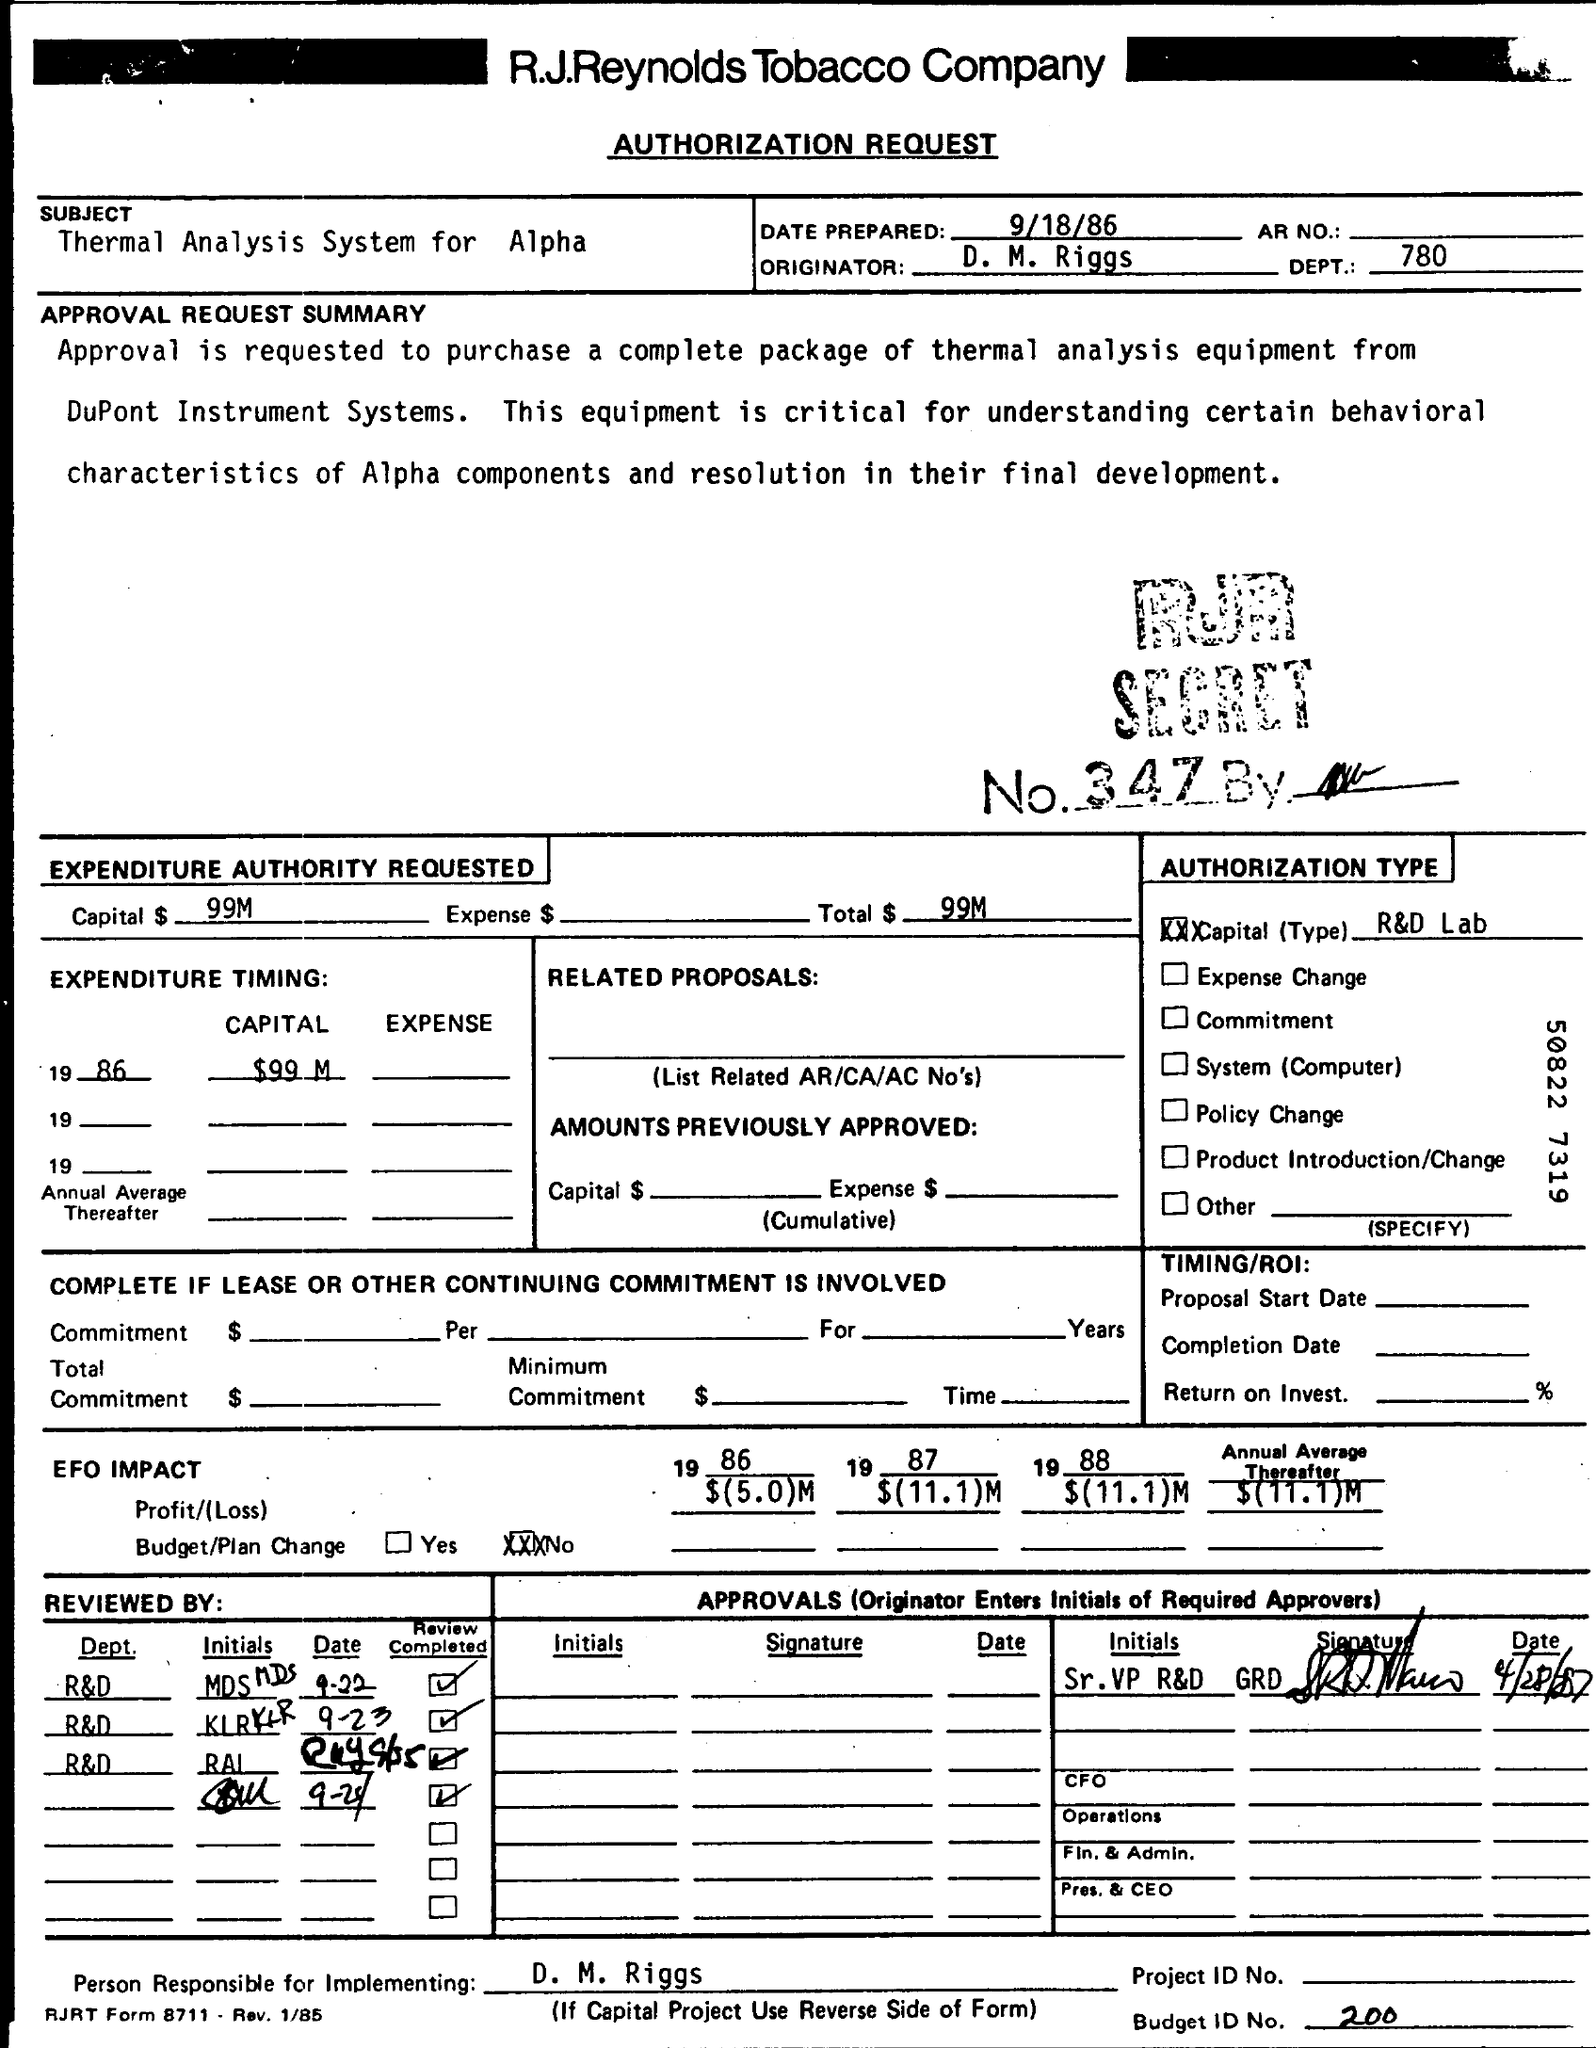What is the subject of the letter ?
Keep it short and to the point. Thermal analysis System for alpha. Who is the orginator ?
Offer a very short reply. D. M. Riggs. What is the budget id number ?
Offer a terse response. 200. 